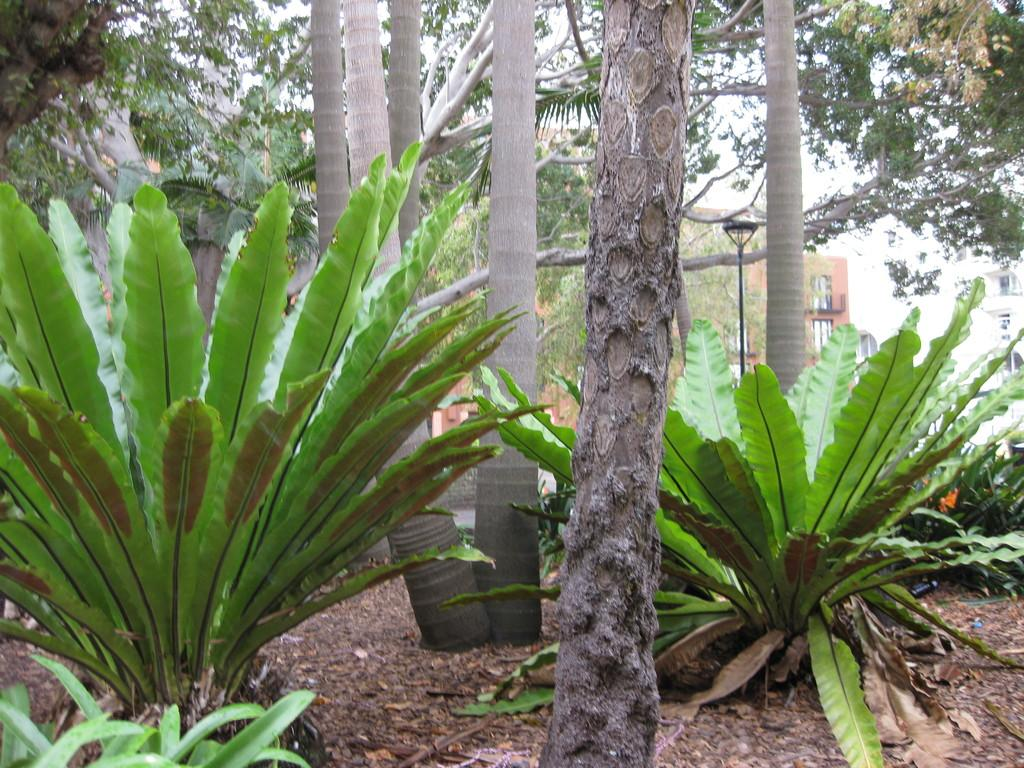What type of vegetation can be seen in the image? There are many plants and trees in the image. What can be seen in the background of the image? There is a light pole and buildings in the background of the image. What type of record can be heard playing in the background of the image? There is no record playing in the background of the image, as it is a still image and not a video or audio recording. 